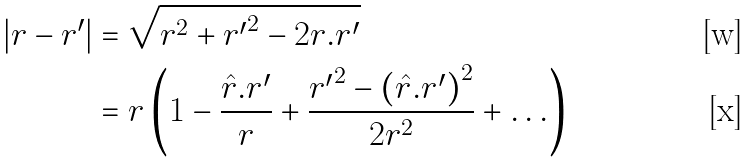<formula> <loc_0><loc_0><loc_500><loc_500>\left | { { r } - { r ^ { \prime } } } \right | & = \sqrt { r ^ { 2 } + { r ^ { \prime } } ^ { 2 } - 2 { r } { . r ^ { \prime } } } \\ & = r \left ( { 1 - \frac { { { \hat { r } } { . r ^ { \prime } } } } { r } + \frac { { { r ^ { \prime } } ^ { 2 } - \left ( { { \hat { r } } { . r ^ { \prime } } } \right ) ^ { 2 } } } { 2 r ^ { 2 } } + \dots } \right )</formula> 